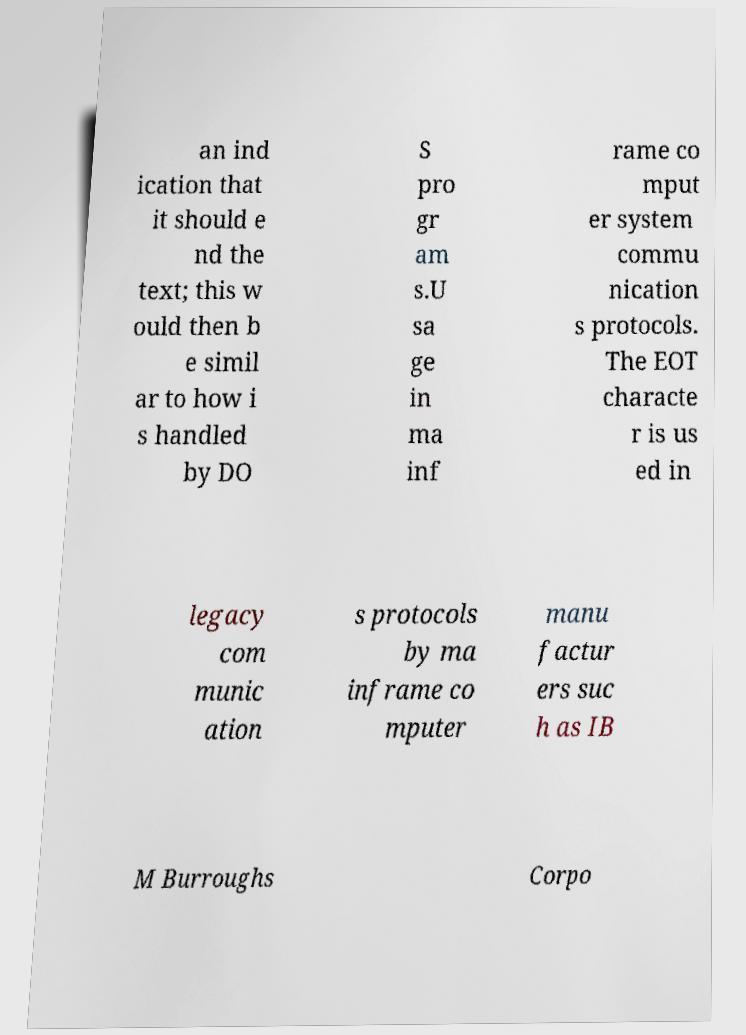Please identify and transcribe the text found in this image. an ind ication that it should e nd the text; this w ould then b e simil ar to how i s handled by DO S pro gr am s.U sa ge in ma inf rame co mput er system commu nication s protocols. The EOT characte r is us ed in legacy com munic ation s protocols by ma inframe co mputer manu factur ers suc h as IB M Burroughs Corpo 